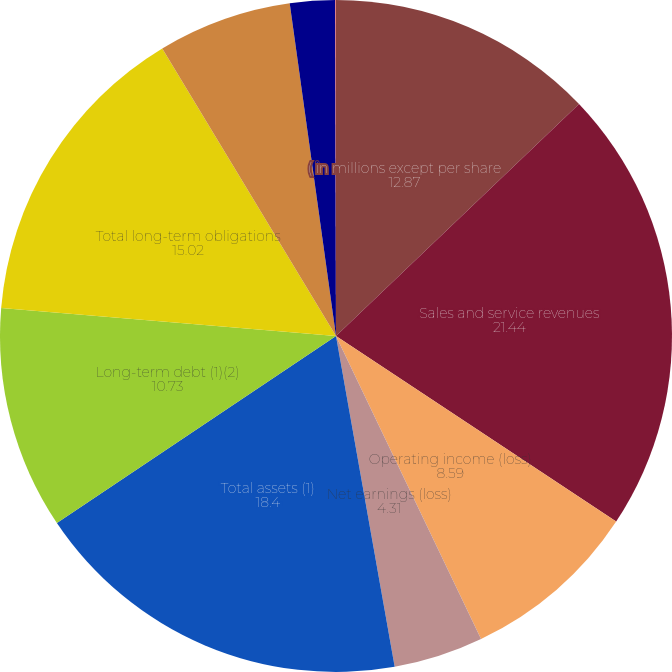<chart> <loc_0><loc_0><loc_500><loc_500><pie_chart><fcel>( in millions except per share<fcel>Sales and service revenues<fcel>Operating income (loss)<fcel>Net earnings (loss)<fcel>Total assets (1)<fcel>Long-term debt (1)(2)<fcel>Total long-term obligations<fcel>Free cash flow (3)<fcel>Basic earnings (loss) per<fcel>Diluted earnings (loss) per<nl><fcel>12.87%<fcel>21.44%<fcel>8.59%<fcel>4.31%<fcel>18.4%<fcel>10.73%<fcel>15.02%<fcel>6.45%<fcel>2.17%<fcel>0.03%<nl></chart> 